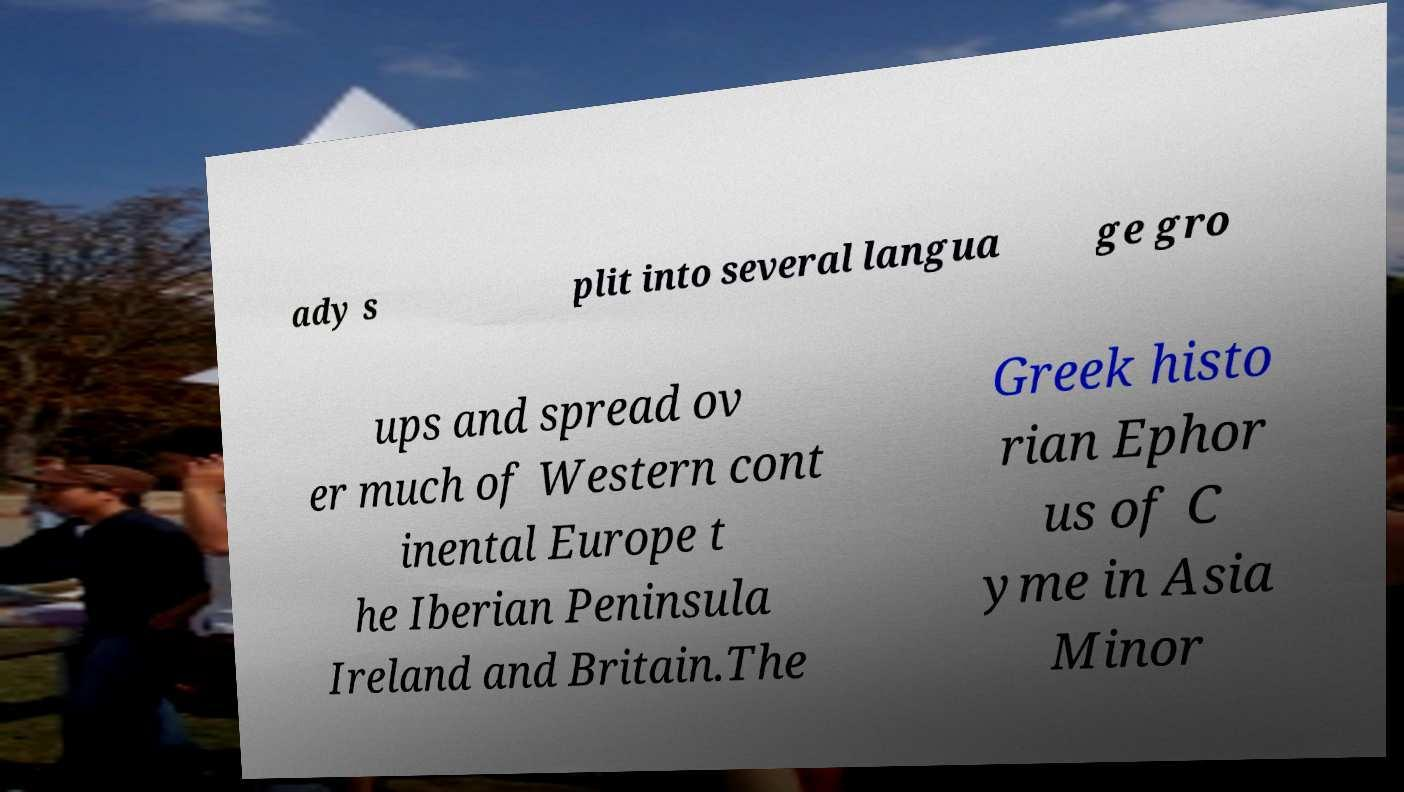Can you read and provide the text displayed in the image?This photo seems to have some interesting text. Can you extract and type it out for me? ady s plit into several langua ge gro ups and spread ov er much of Western cont inental Europe t he Iberian Peninsula Ireland and Britain.The Greek histo rian Ephor us of C yme in Asia Minor 